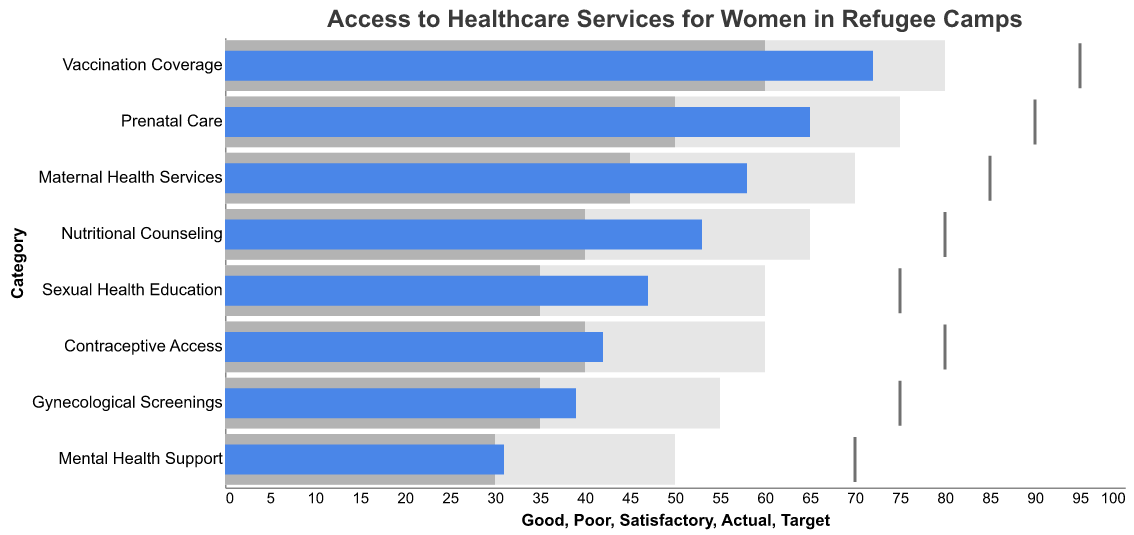What's the target value for prenatal care? The target value for prenatal care can be extracted directly from the figure by locating the target tick on the corresponding bar for prenatal care.
Answer: 90 What is the lowest actual value recorded for any healthcare service? To find the lowest actual value, one needs to examine the actual values represented by the blue bars in the figure for all categories.
Answer: 31 How much higher is the target for vaccination coverage compared to its actual value? The target for vaccination coverage is 95 and the actual value is 72. The difference can be calculated as 95 - 72.
Answer: 23 Which healthcare service has the smallest gap between the actual and satisfactory thresholds? To find this, compare the difference between the actual and satisfactory thresholds for each category. The smallest gap is found by calculating the differences: Prenatal Care (15), Maternal Health Services (13), Contraceptive Access (2), Gynecological Screenings (4), Mental Health Support (1), Nutritional Counseling (13), Sexual Health Education (12), Vaccination Coverage (12). The smallest gap is for Mental Health Support.
Answer: Mental Health Support Compare the good threshold for nutritional counseling with the actual value of sexual health education. Which is higher? Extract the good threshold for nutritional counseling (65) and compare it to the actual value of sexual health education (47). Since 65 is greater than 47, the good threshold is higher.
Answer: Good threshold for nutritional counseling How many healthcare services have actual values that meet or exceed the satisfactory threshold? Compare the actual values to their respective satisfactory thresholds for each service. Prenatal Care (65 vs. 50), Nutritional Counseling (53 vs. 40), and Vaccination Coverage (72 vs. 60) meet or exceed the satisfactory threshold. Therefore, 3 services meet or exceed the satisfactory threshold.
Answer: 3 Which category has the highest target value? Examine the target values represented by the ticks for all categories and identify the highest. Vaccination Coverage has the highest target value of 95.
Answer: Vaccination Coverage What percentage of the target is achieved for contraceptive access? The target for contraceptive access is 80 and the actual value is 42. Percentage achieved is calculated as (42/80) * 100.
Answer: 52.5% What is the average actual value for all healthcare services? Sum the actual values (65 + 58 + 42 + 39 + 31 + 53 + 47 + 72) and divide by the number of services (8). The sum is 407, so the average is 407 / 8.
Answer: 50.875 For which healthcare service is the gap between the actual and target values the greatest? Calculate the difference between the target and actual values for each service: Prenatal Care (25), Maternal Health Services (27), Contraceptive Access (38), Gynecological Screenings (36), Mental Health Support (39), Nutritional Counseling (27), Sexual Health Education (28), Vaccination Coverage (23). The largest gap is for Mental Health Support.
Answer: Mental Health Support 